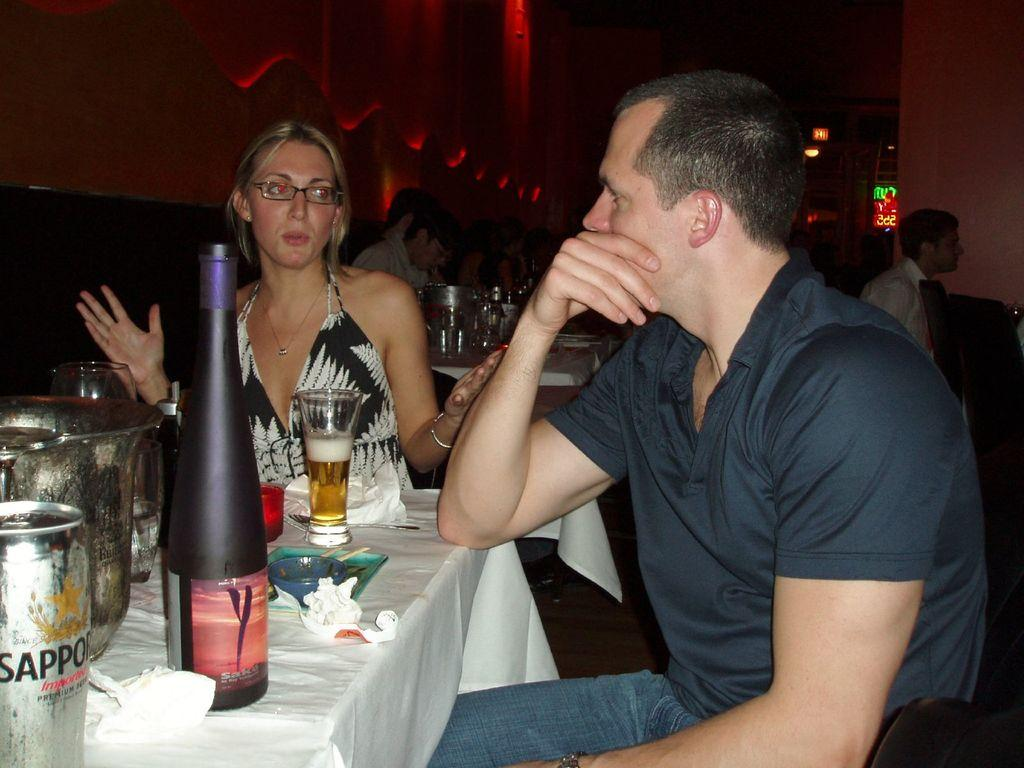Provide a one-sentence caption for the provided image. A couple are drinking Sapporo beer at a restaurant. 